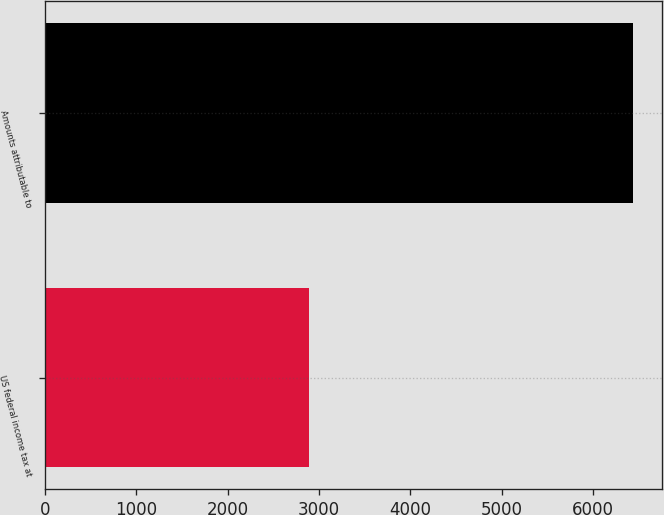<chart> <loc_0><loc_0><loc_500><loc_500><bar_chart><fcel>US federal income tax at<fcel>Amounts attributable to<nl><fcel>2893<fcel>6429<nl></chart> 